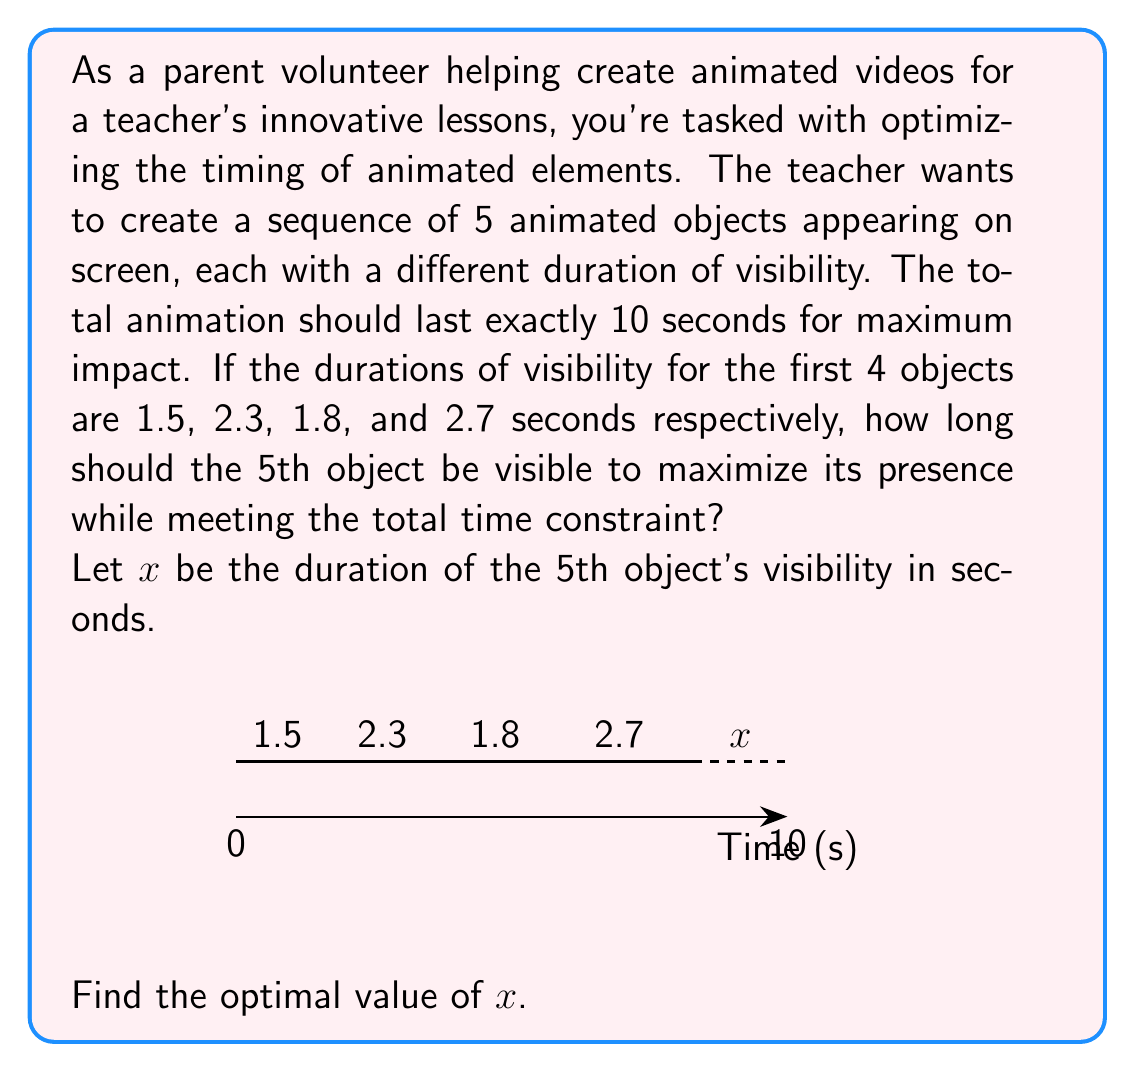Can you answer this question? Let's approach this step-by-step:

1) First, we need to set up an equation based on the given information. The sum of all durations should equal 10 seconds:

   $1.5 + 2.3 + 1.8 + 2.7 + x = 10$

2) Let's simplify the left side of the equation:

   $8.3 + x = 10$

3) Now, we can solve for $x$:

   $x = 10 - 8.3$
   $x = 1.7$

4) To verify, let's sum up all durations including our result:

   $1.5 + 2.3 + 1.8 + 2.7 + 1.7 = 10$

5) The equation holds true, confirming our solution.

Therefore, to maximize the presence of the 5th object while meeting the total time constraint of 10 seconds, it should be visible for 1.7 seconds.
Answer: $x = 1.7$ seconds 